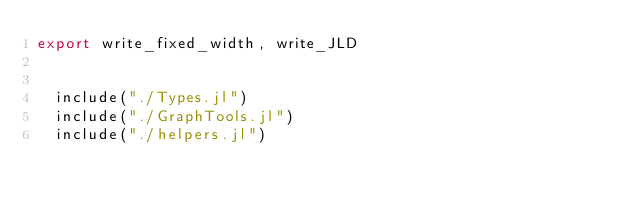Convert code to text. <code><loc_0><loc_0><loc_500><loc_500><_Julia_>export write_fixed_width, write_JLD


  include("./Types.jl")
  include("./GraphTools.jl")
  include("./helpers.jl")</code> 